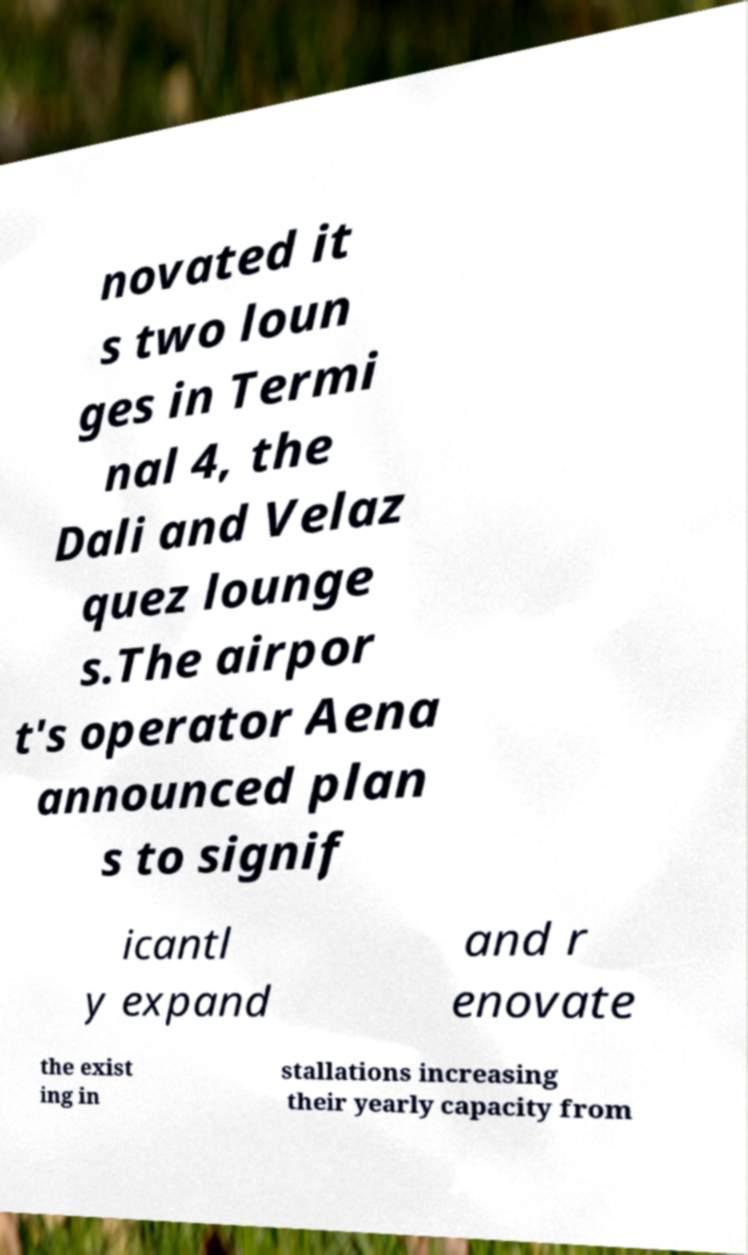For documentation purposes, I need the text within this image transcribed. Could you provide that? novated it s two loun ges in Termi nal 4, the Dali and Velaz quez lounge s.The airpor t's operator Aena announced plan s to signif icantl y expand and r enovate the exist ing in stallations increasing their yearly capacity from 